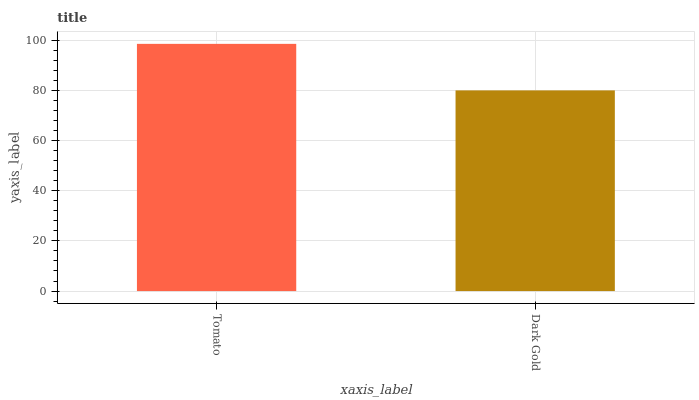Is Dark Gold the minimum?
Answer yes or no. Yes. Is Tomato the maximum?
Answer yes or no. Yes. Is Dark Gold the maximum?
Answer yes or no. No. Is Tomato greater than Dark Gold?
Answer yes or no. Yes. Is Dark Gold less than Tomato?
Answer yes or no. Yes. Is Dark Gold greater than Tomato?
Answer yes or no. No. Is Tomato less than Dark Gold?
Answer yes or no. No. Is Tomato the high median?
Answer yes or no. Yes. Is Dark Gold the low median?
Answer yes or no. Yes. Is Dark Gold the high median?
Answer yes or no. No. Is Tomato the low median?
Answer yes or no. No. 